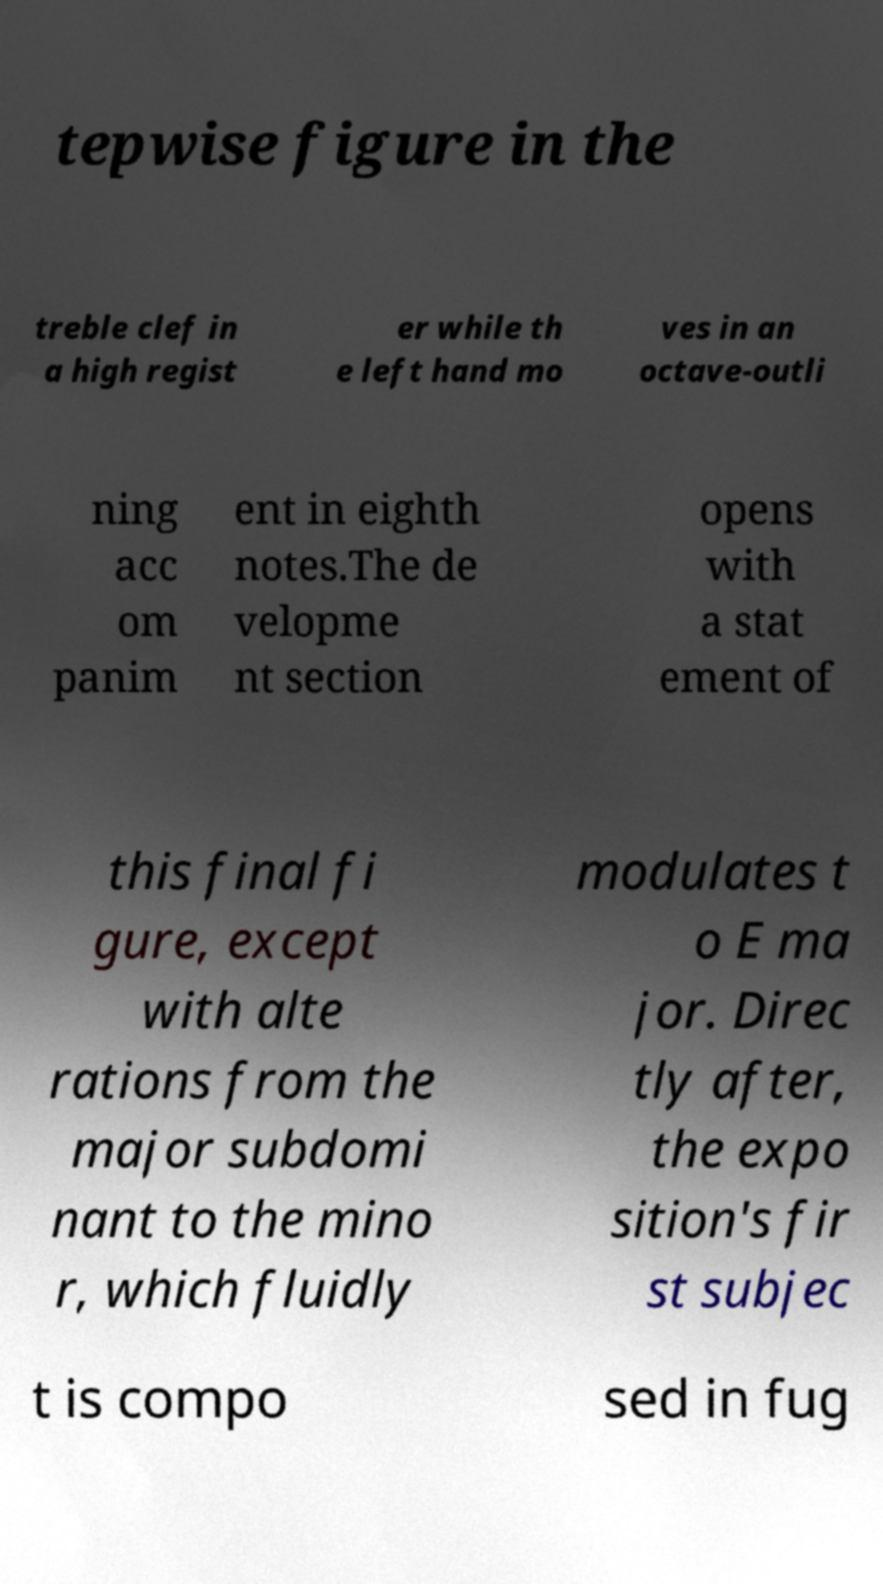Could you assist in decoding the text presented in this image and type it out clearly? tepwise figure in the treble clef in a high regist er while th e left hand mo ves in an octave-outli ning acc om panim ent in eighth notes.The de velopme nt section opens with a stat ement of this final fi gure, except with alte rations from the major subdomi nant to the mino r, which fluidly modulates t o E ma jor. Direc tly after, the expo sition's fir st subjec t is compo sed in fug 